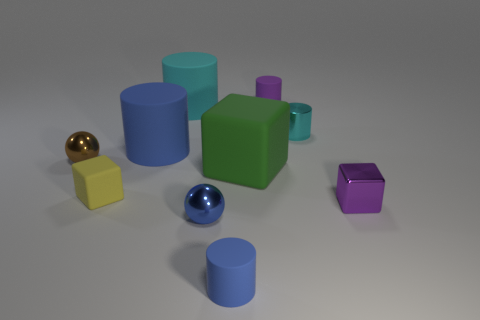How does the lighting in this image affect the way the colors of the objects appear? The lighting in the image, coming from the top left, accentuates the colors of the objects by creating soft shadows and highlights. This directional lighting helps to bring out the texture and color saturation, making the hues more vibrant. The surfaces closer to the light source reflect more light, which can slightly alter our perception of their color. 